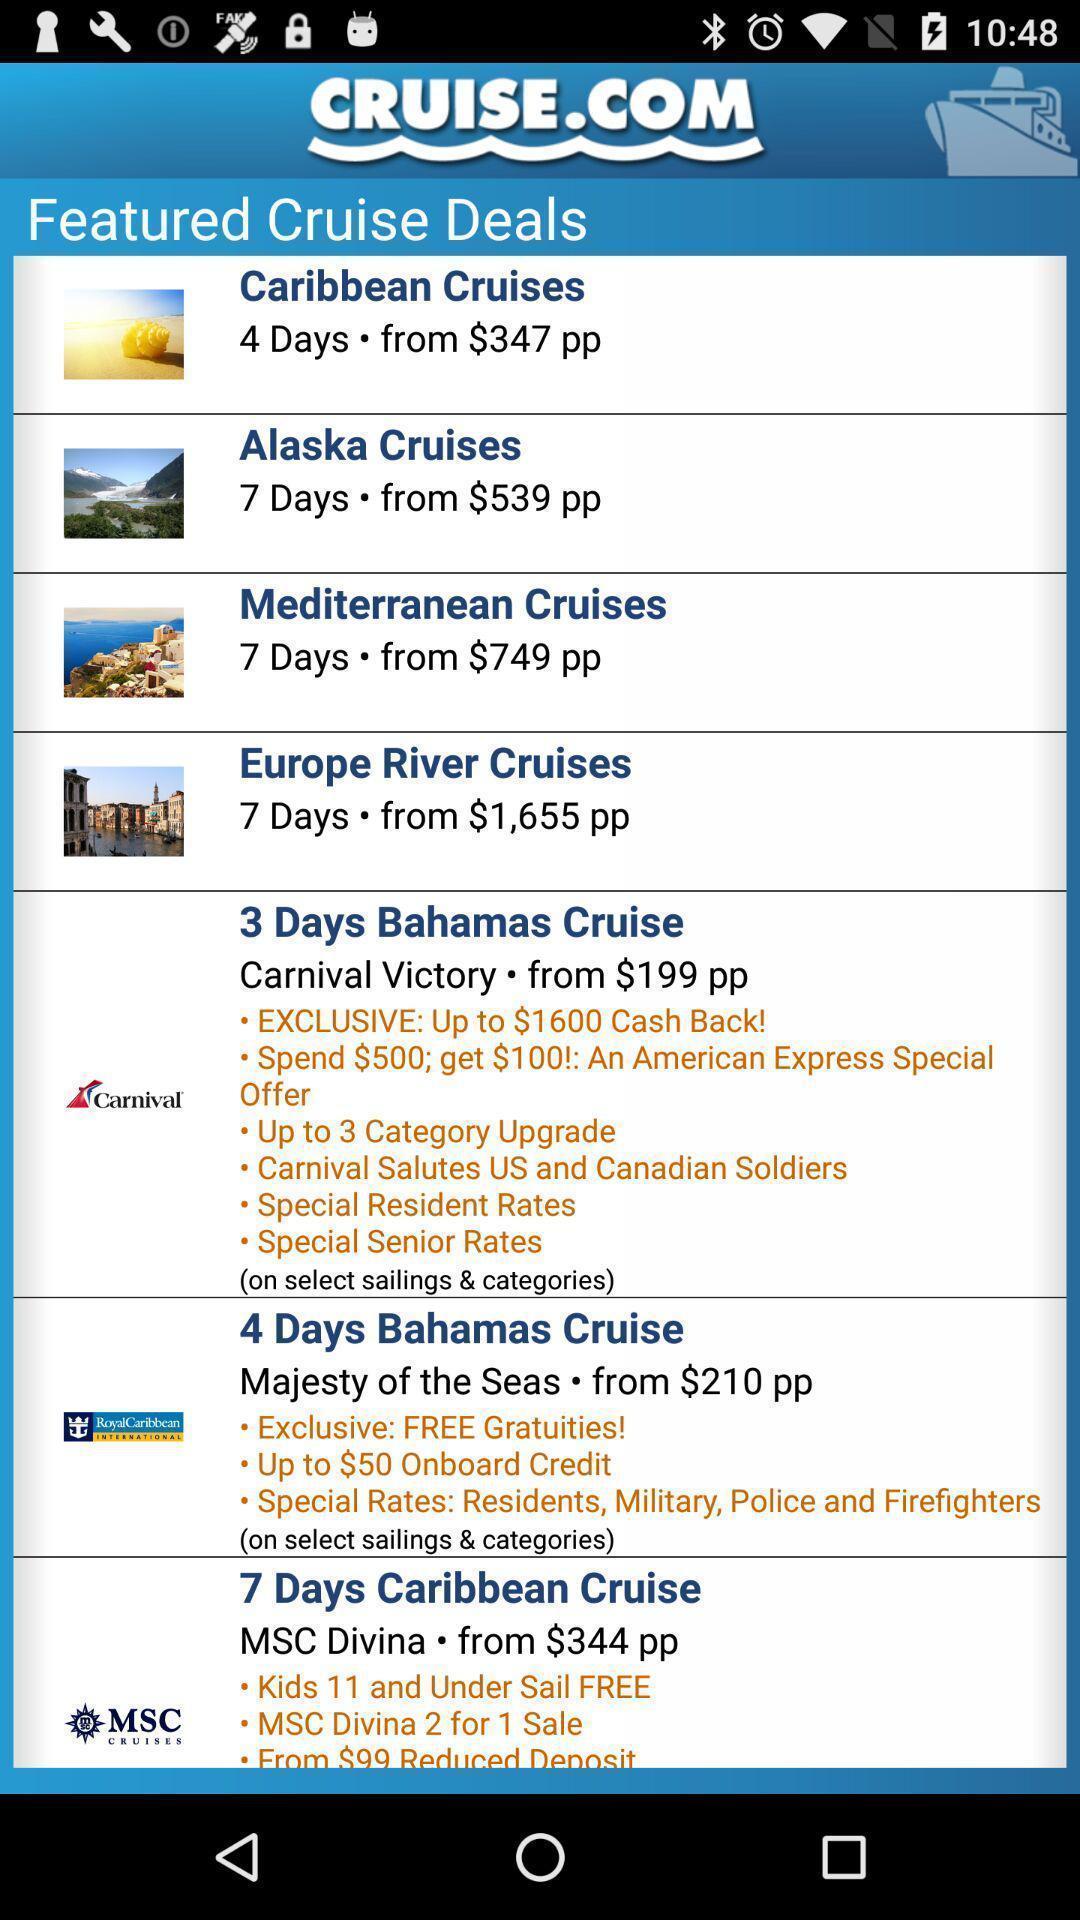What details can you identify in this image? Page displaying various cruise deals. 